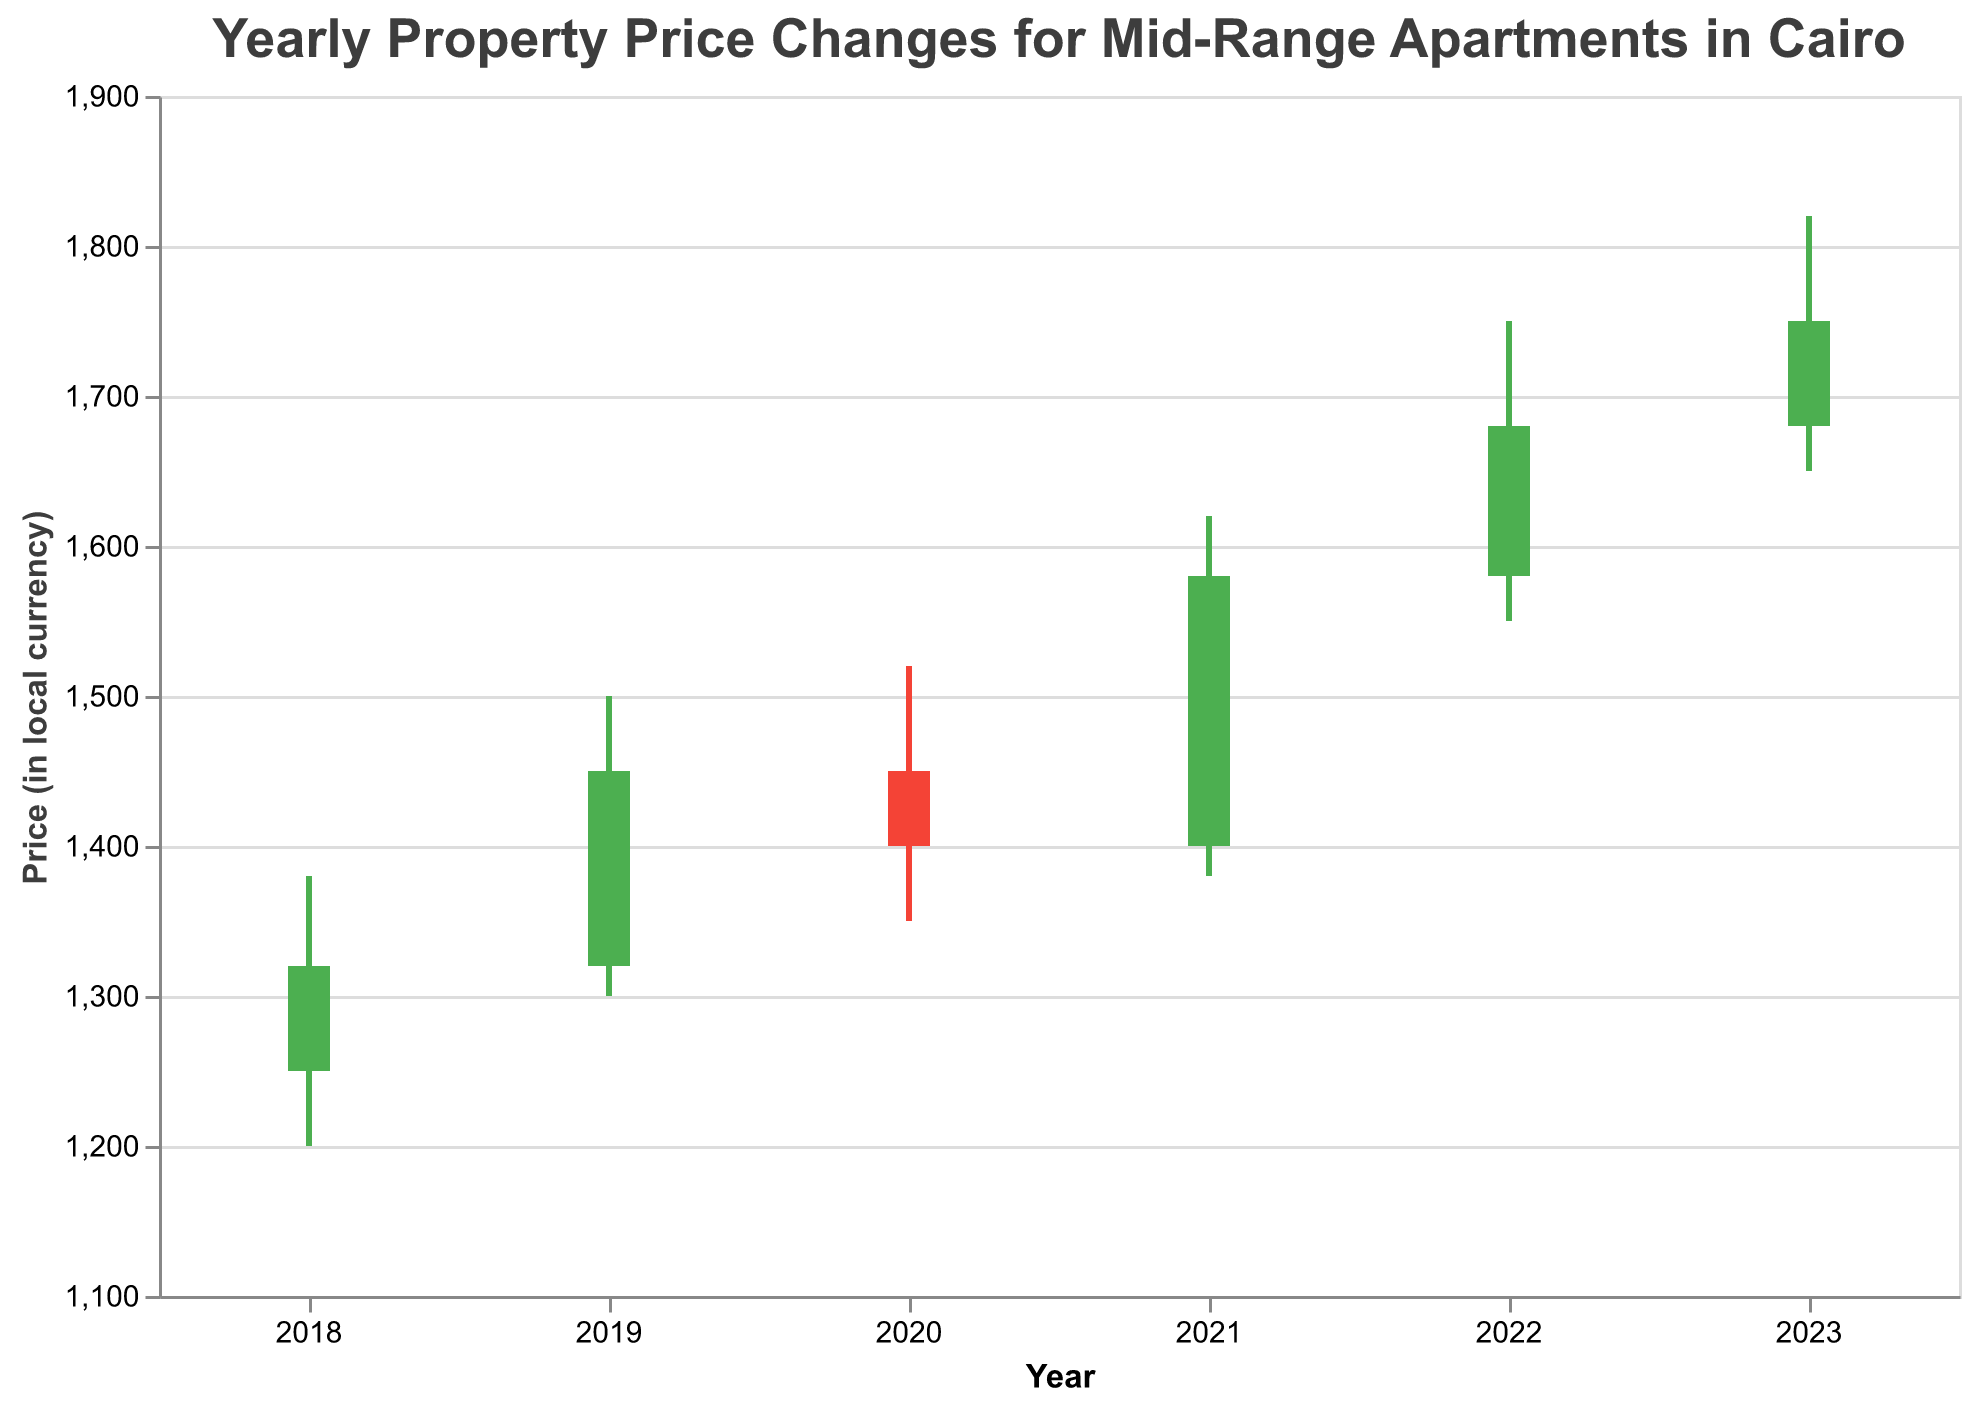What is the highest property price recorded in 2020? Look at the "High" price for the year 2020. The highest price recorded is 1520.
Answer: 1520 What is the difference between the opening price in 2022 and 2023? Subtract the opening price in 2022 (1580) from the opening price in 2023 (1680). Difference = 1680 - 1580 = 100.
Answer: 100 Which year experienced the lowest property price? Look for the lowest "Low" value across all years. The lowest value is 1200, which occurred in 2018.
Answer: 2018 In which year did the property prices close higher than they opened? Identify years where the "Close" value is higher than the "Open" value. These years are 2018, 2019, 2021, 2022, and 2023.
Answer: 2018, 2019, 2021, 2022, 2023 What’s the relationship between the highest and the lowest prices in 2021? Look at the "High" and "Low" prices for the year 2021. The highest price is 1620, and the lowest price is 1380. The difference is 1620 - 1380 = 240.
Answer: 240 How many years have a higher closing price compared to the opening price? Count the years where the "Close" price is higher than the "Open" price. The years are 2018, 2019, 2021, 2022, and 2023, giving us 5 years.
Answer: 5 Which year showed a decrease in the property prices from opening to closing? Identify years where the "Close" price is lower than the "Open" price. This happened in 2020.
Answer: 2020 What was the price range (difference between high and low) in 2019? Subtract the "Low" price from the "High" price for the year 2019. Price range = 1500 - 1300 = 200.
Answer: 200 